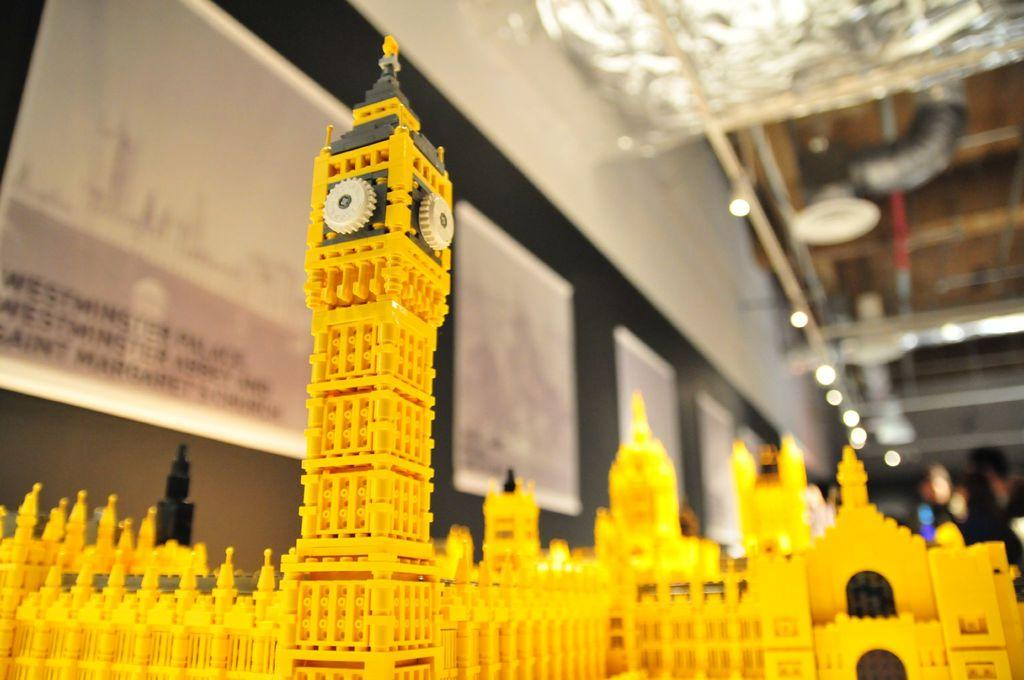What is the main subject of the image? The main subject of the image is a structure made up of legos. What can be seen in the background of the image? In the background of the image, there are advertisements attached to the wall, electric lights, pipelines, and persons. Can you describe the structure made up of legos? Unfortunately, the specific details of the lego structure cannot be determined from the provided facts. What type of blood is being used to write the advertisements in the image? There is no blood present in the image, and the advertisements are not written in blood. 